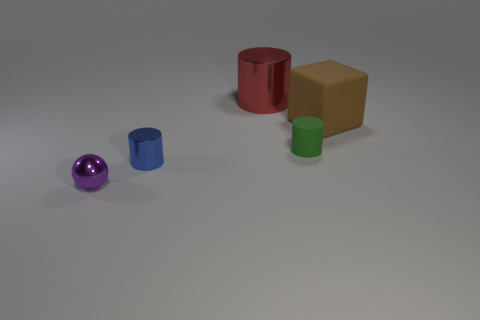Subtract all tiny cylinders. How many cylinders are left? 1 Subtract all cylinders. How many objects are left? 2 Subtract all green cubes. How many brown balls are left? 0 Subtract all green rubber objects. Subtract all big red shiny cylinders. How many objects are left? 3 Add 1 large brown matte cubes. How many large brown matte cubes are left? 2 Add 5 blue objects. How many blue objects exist? 6 Add 3 large metallic cylinders. How many objects exist? 8 Subtract 0 blue balls. How many objects are left? 5 Subtract 3 cylinders. How many cylinders are left? 0 Subtract all blue balls. Subtract all blue cylinders. How many balls are left? 1 